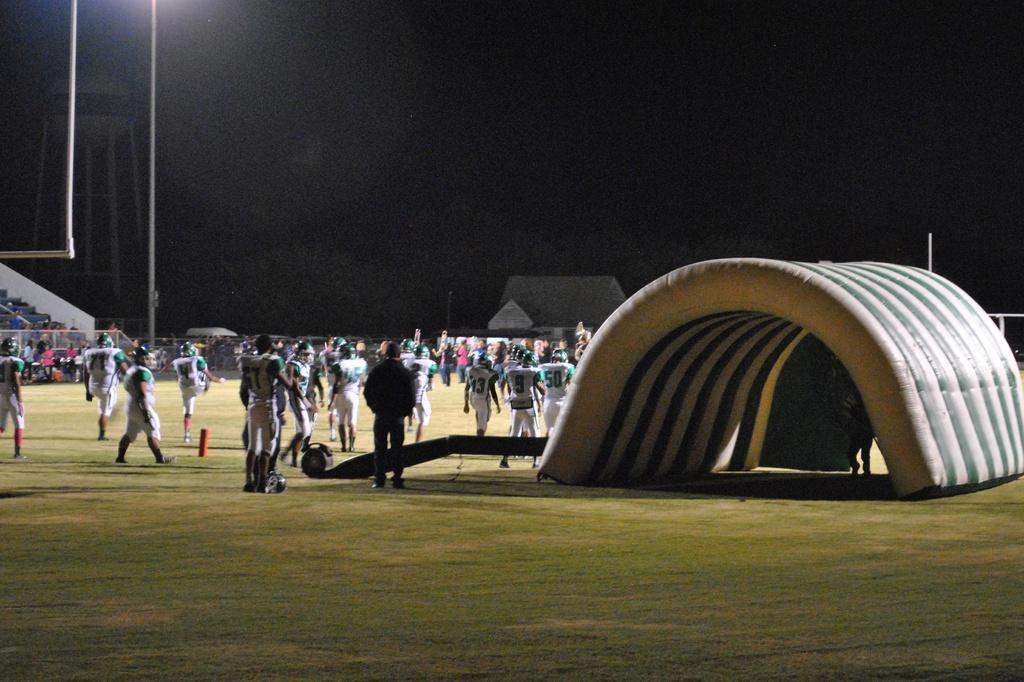Could you give a brief overview of what you see in this image? In this image I can see number of persons are standing on the ground and a air bag which is white and green in color. In the background I can see the stadium, a pole and the dark sky. 